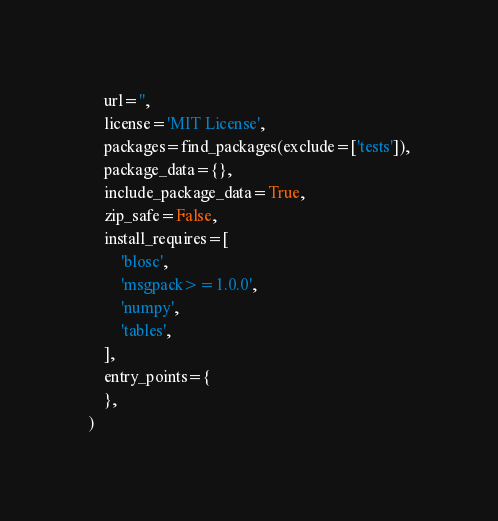Convert code to text. <code><loc_0><loc_0><loc_500><loc_500><_Python_>    url='',
    license='MIT License',
    packages=find_packages(exclude=['tests']),
    package_data={},
    include_package_data=True,
    zip_safe=False,
    install_requires=[
        'blosc',
        'msgpack>=1.0.0',
        'numpy',
        'tables',
    ],
    entry_points={
    },
)</code> 